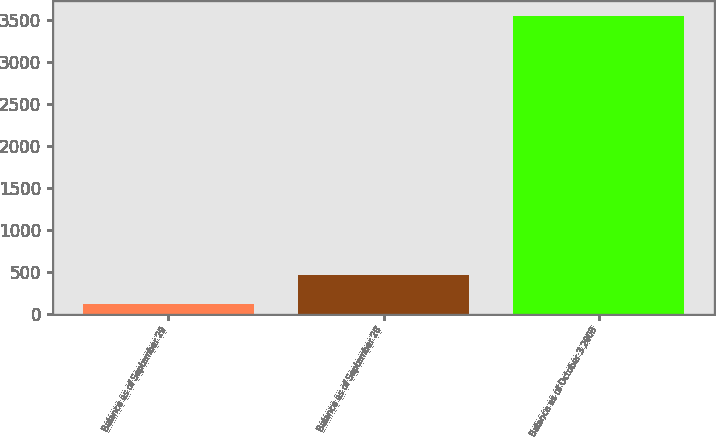<chart> <loc_0><loc_0><loc_500><loc_500><bar_chart><fcel>Balance as of September 29<fcel>Balance as of September 28<fcel>Balance as of October 3 2008<nl><fcel>122<fcel>464.7<fcel>3549<nl></chart> 